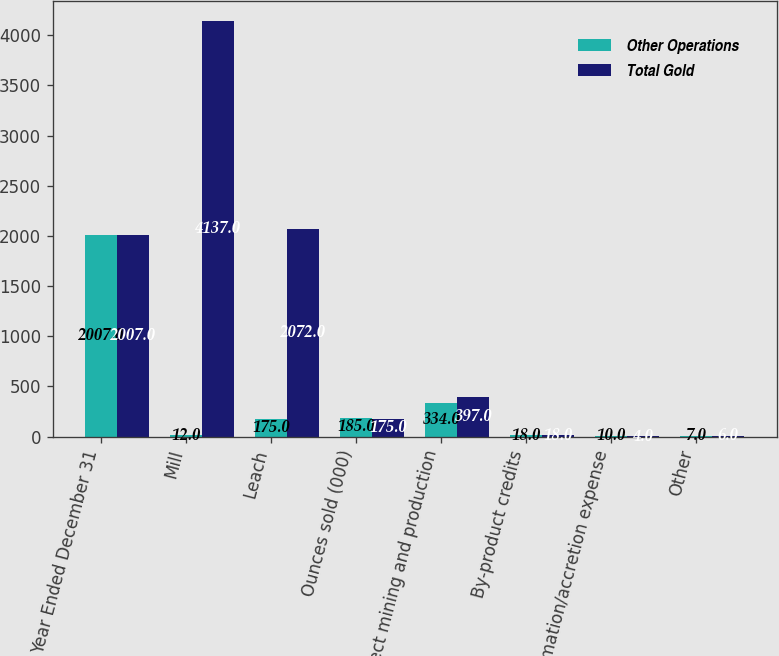Convert chart. <chart><loc_0><loc_0><loc_500><loc_500><stacked_bar_chart><ecel><fcel>Year Ended December 31<fcel>Mill<fcel>Leach<fcel>Ounces sold (000)<fcel>Direct mining and production<fcel>By-product credits<fcel>Reclamation/accretion expense<fcel>Other<nl><fcel>Other Operations<fcel>2007<fcel>12<fcel>175<fcel>185<fcel>334<fcel>18<fcel>10<fcel>7<nl><fcel>Total Gold<fcel>2007<fcel>4137<fcel>2072<fcel>175<fcel>397<fcel>18<fcel>4<fcel>6<nl></chart> 